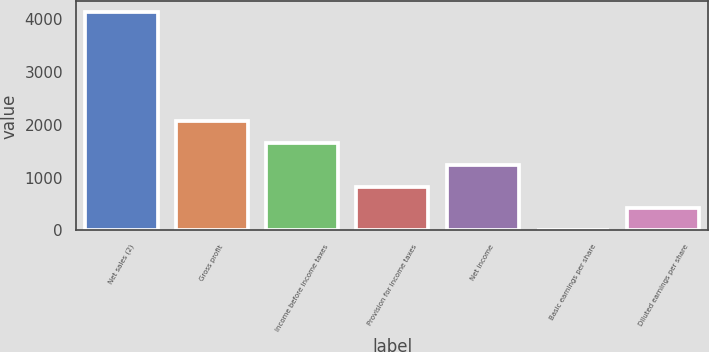Convert chart to OTSL. <chart><loc_0><loc_0><loc_500><loc_500><bar_chart><fcel>Net sales (2)<fcel>Gross profit<fcel>Income before income taxes<fcel>Provision for income taxes<fcel>Net income<fcel>Basic earnings per share<fcel>Diluted earnings per share<nl><fcel>4135<fcel>2067.69<fcel>1654.22<fcel>827.28<fcel>1240.75<fcel>0.34<fcel>413.81<nl></chart> 